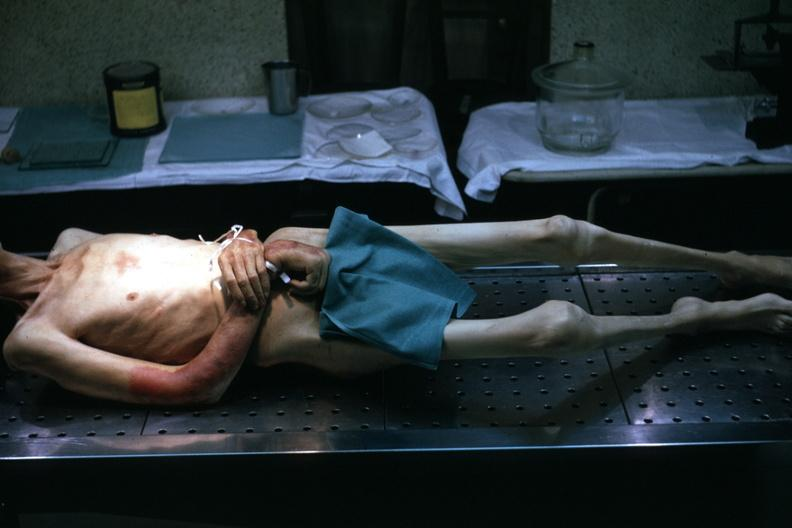s muscle atrophy striking?
Answer the question using a single word or phrase. Yes 